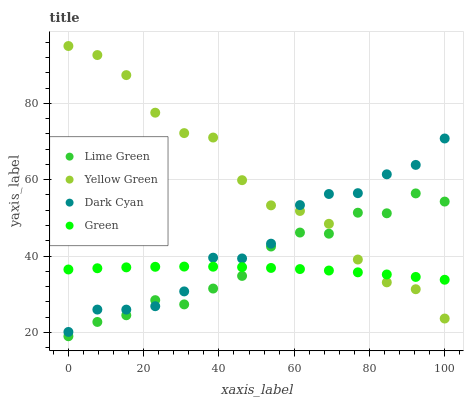Does Green have the minimum area under the curve?
Answer yes or no. Yes. Does Yellow Green have the maximum area under the curve?
Answer yes or no. Yes. Does Lime Green have the minimum area under the curve?
Answer yes or no. No. Does Lime Green have the maximum area under the curve?
Answer yes or no. No. Is Green the smoothest?
Answer yes or no. Yes. Is Yellow Green the roughest?
Answer yes or no. Yes. Is Lime Green the smoothest?
Answer yes or no. No. Is Lime Green the roughest?
Answer yes or no. No. Does Lime Green have the lowest value?
Answer yes or no. Yes. Does Green have the lowest value?
Answer yes or no. No. Does Yellow Green have the highest value?
Answer yes or no. Yes. Does Lime Green have the highest value?
Answer yes or no. No. Does Lime Green intersect Dark Cyan?
Answer yes or no. Yes. Is Lime Green less than Dark Cyan?
Answer yes or no. No. Is Lime Green greater than Dark Cyan?
Answer yes or no. No. 